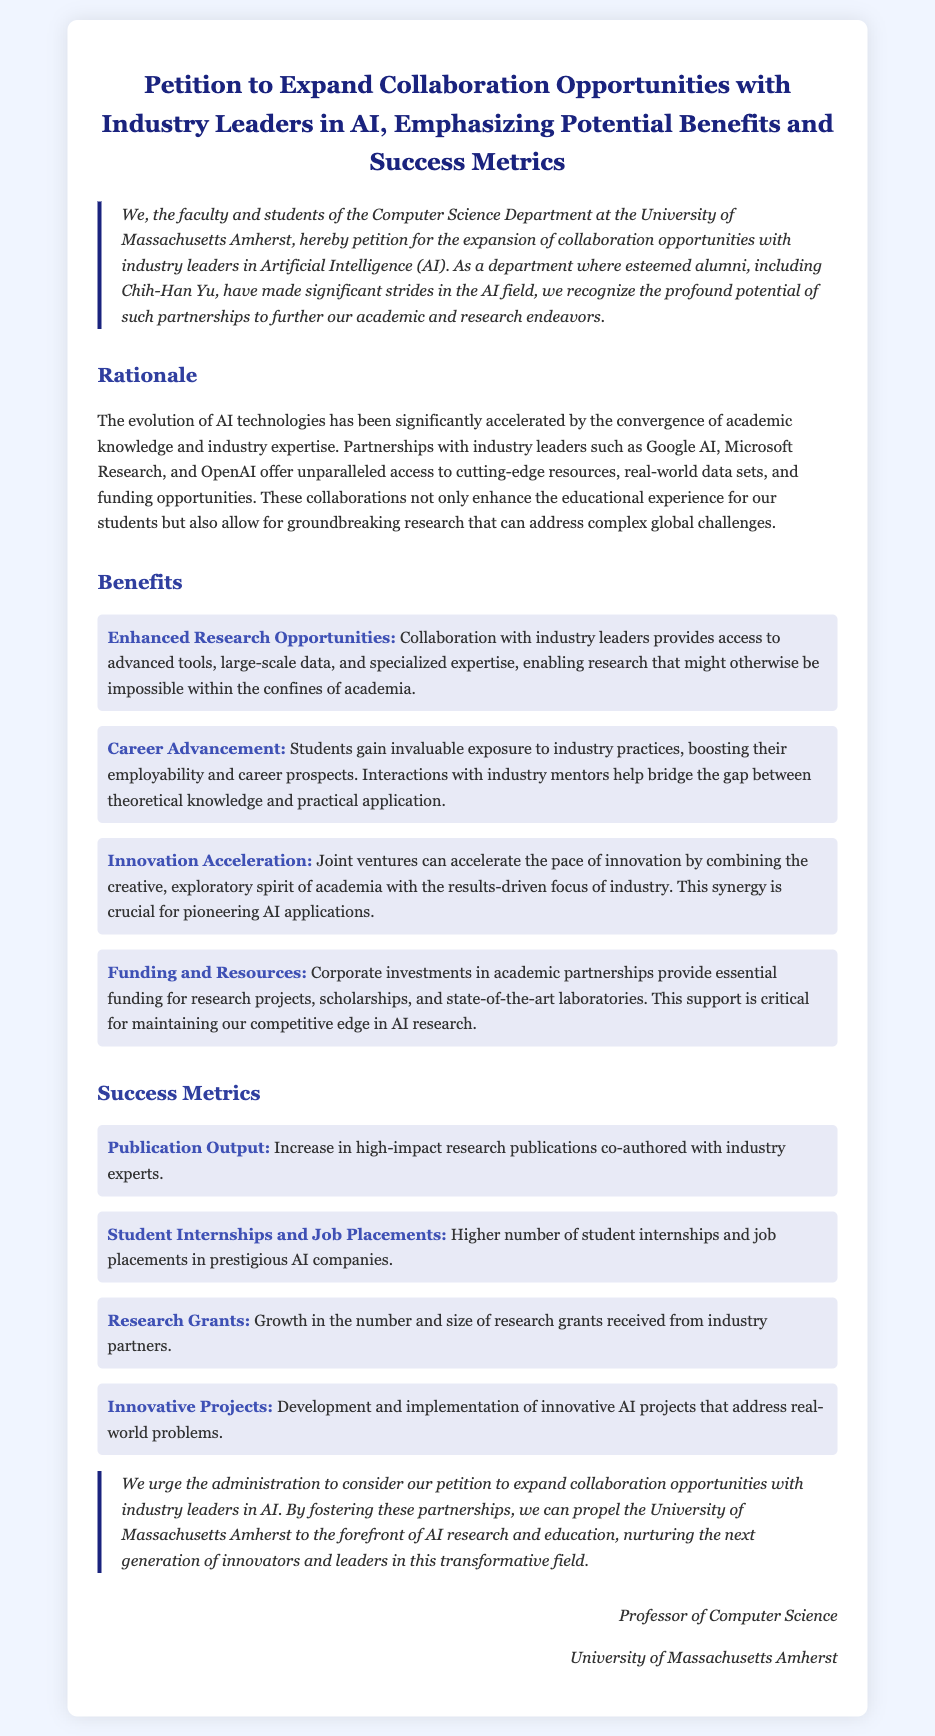What is the title of the petition? The title of the petition is stated at the beginning of the document and focuses on expanding collaboration opportunities in AI.
Answer: Petition to Expand Collaboration Opportunities with Industry Leaders in AI, Emphasizing Potential Benefits and Success Metrics Who is the petition addressed to? The petition is directed towards the administration of the university, as indicated in the conclusion.
Answer: Administration What university is the petition from? The petition states the affiliation of the signers, which includes students and faculty from a specific university.
Answer: University of Massachusetts Amherst Name one industry leader mentioned in the document. The document lists several industry leaders that could potentially collaborate, one of which is explicitly mentioned.
Answer: Google AI What benefit does the petition highlight related to funding? The petition outlines various benefits of collaboration, particularly mentioning financial aspects.
Answer: Corporate investments What is one success metric related to student careers? The document specifies metrics that gauge the effectiveness of industry collaborations, notably regarding students' professional development.
Answer: Higher number of student internships and job placements in prestigious AI companies How many specific benefits are detailed in the document? The document elaborates on a distinct number of benefits associated with collaboration opportunities in AI.
Answer: Four What is emphasized as a crucial aspect of industry-academic partnerships? The petition conveys a significant theme that underscores the importance of merging different focuses in research and innovation.
Answer: Synergy 